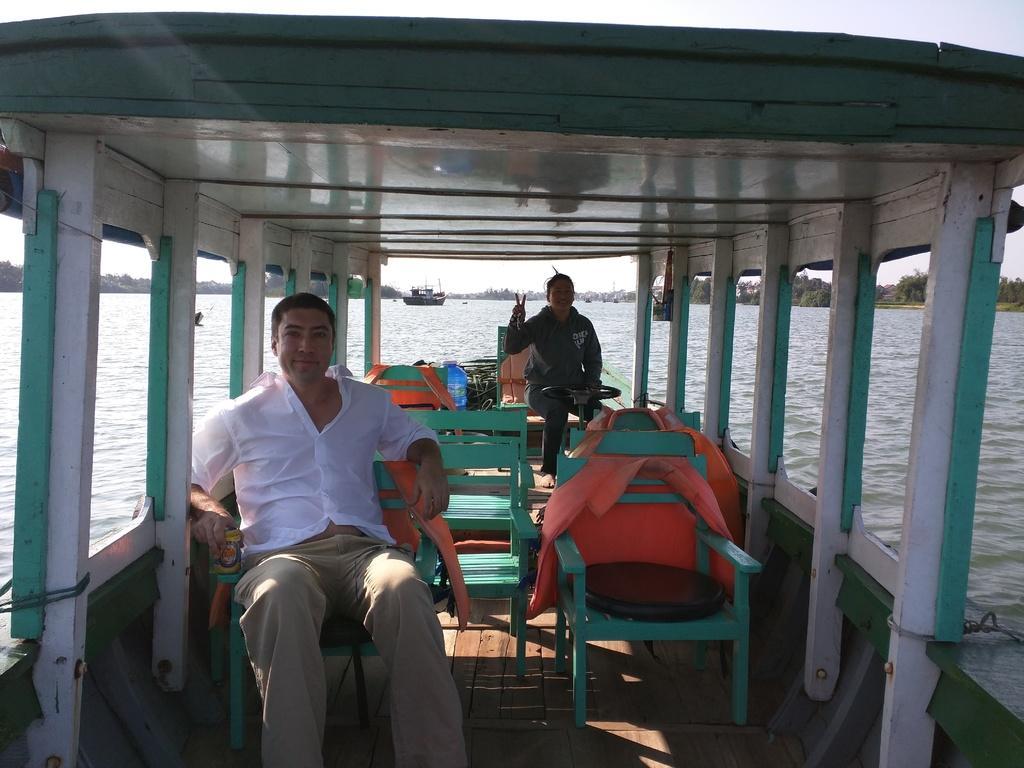Can you describe this image briefly? There is a man and woman riding in the boat on water. In the background there are trees,ship and a sky. 